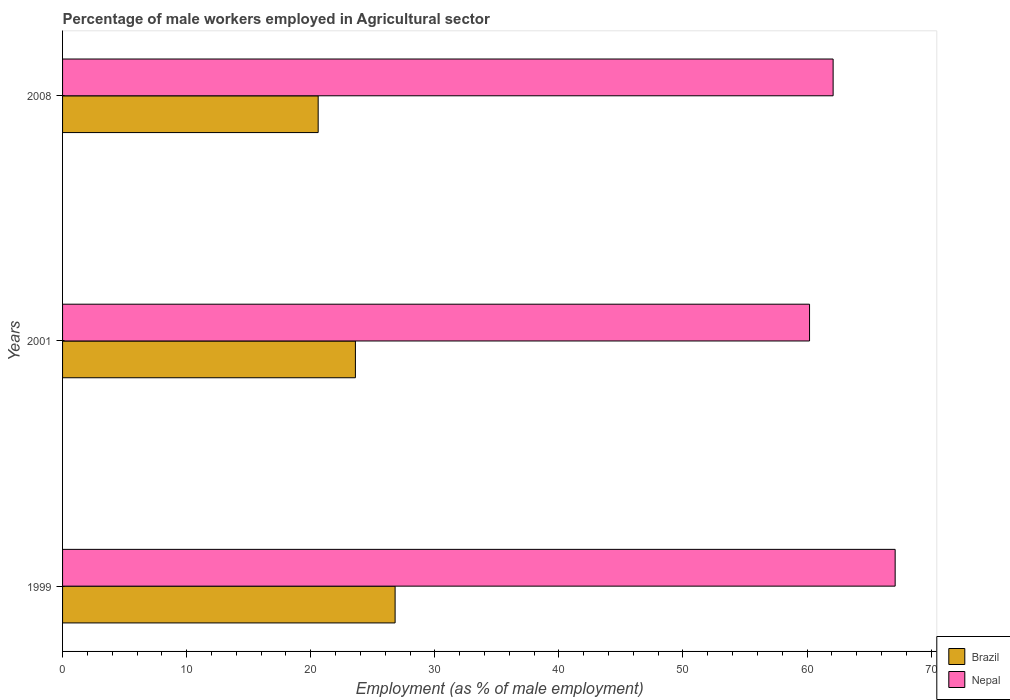How many groups of bars are there?
Your answer should be very brief. 3. Are the number of bars per tick equal to the number of legend labels?
Provide a succinct answer. Yes. What is the label of the 3rd group of bars from the top?
Give a very brief answer. 1999. What is the percentage of male workers employed in Agricultural sector in Nepal in 2008?
Provide a succinct answer. 62.1. Across all years, what is the maximum percentage of male workers employed in Agricultural sector in Nepal?
Your answer should be compact. 67.1. Across all years, what is the minimum percentage of male workers employed in Agricultural sector in Nepal?
Offer a very short reply. 60.2. In which year was the percentage of male workers employed in Agricultural sector in Nepal maximum?
Provide a short and direct response. 1999. What is the total percentage of male workers employed in Agricultural sector in Brazil in the graph?
Your response must be concise. 71. What is the difference between the percentage of male workers employed in Agricultural sector in Nepal in 1999 and that in 2001?
Ensure brevity in your answer.  6.9. What is the difference between the percentage of male workers employed in Agricultural sector in Brazil in 1999 and the percentage of male workers employed in Agricultural sector in Nepal in 2001?
Your answer should be very brief. -33.4. What is the average percentage of male workers employed in Agricultural sector in Brazil per year?
Provide a short and direct response. 23.67. In the year 2001, what is the difference between the percentage of male workers employed in Agricultural sector in Brazil and percentage of male workers employed in Agricultural sector in Nepal?
Provide a short and direct response. -36.6. In how many years, is the percentage of male workers employed in Agricultural sector in Nepal greater than 14 %?
Your response must be concise. 3. What is the ratio of the percentage of male workers employed in Agricultural sector in Brazil in 1999 to that in 2001?
Your answer should be compact. 1.14. Is the percentage of male workers employed in Agricultural sector in Brazil in 2001 less than that in 2008?
Provide a short and direct response. No. What is the difference between the highest and the second highest percentage of male workers employed in Agricultural sector in Brazil?
Provide a short and direct response. 3.2. What is the difference between the highest and the lowest percentage of male workers employed in Agricultural sector in Nepal?
Ensure brevity in your answer.  6.9. Is the sum of the percentage of male workers employed in Agricultural sector in Brazil in 1999 and 2001 greater than the maximum percentage of male workers employed in Agricultural sector in Nepal across all years?
Your answer should be compact. No. What does the 2nd bar from the bottom in 2008 represents?
Give a very brief answer. Nepal. How many years are there in the graph?
Keep it short and to the point. 3. What is the difference between two consecutive major ticks on the X-axis?
Provide a succinct answer. 10. Does the graph contain any zero values?
Give a very brief answer. No. Does the graph contain grids?
Keep it short and to the point. No. What is the title of the graph?
Provide a succinct answer. Percentage of male workers employed in Agricultural sector. What is the label or title of the X-axis?
Make the answer very short. Employment (as % of male employment). What is the label or title of the Y-axis?
Provide a succinct answer. Years. What is the Employment (as % of male employment) in Brazil in 1999?
Keep it short and to the point. 26.8. What is the Employment (as % of male employment) in Nepal in 1999?
Keep it short and to the point. 67.1. What is the Employment (as % of male employment) in Brazil in 2001?
Ensure brevity in your answer.  23.6. What is the Employment (as % of male employment) in Nepal in 2001?
Your answer should be compact. 60.2. What is the Employment (as % of male employment) in Brazil in 2008?
Offer a terse response. 20.6. What is the Employment (as % of male employment) of Nepal in 2008?
Provide a short and direct response. 62.1. Across all years, what is the maximum Employment (as % of male employment) in Brazil?
Offer a terse response. 26.8. Across all years, what is the maximum Employment (as % of male employment) in Nepal?
Offer a terse response. 67.1. Across all years, what is the minimum Employment (as % of male employment) in Brazil?
Offer a terse response. 20.6. Across all years, what is the minimum Employment (as % of male employment) in Nepal?
Give a very brief answer. 60.2. What is the total Employment (as % of male employment) of Brazil in the graph?
Give a very brief answer. 71. What is the total Employment (as % of male employment) in Nepal in the graph?
Offer a terse response. 189.4. What is the difference between the Employment (as % of male employment) in Brazil in 1999 and that in 2008?
Offer a terse response. 6.2. What is the difference between the Employment (as % of male employment) of Nepal in 1999 and that in 2008?
Give a very brief answer. 5. What is the difference between the Employment (as % of male employment) of Brazil in 2001 and that in 2008?
Give a very brief answer. 3. What is the difference between the Employment (as % of male employment) in Nepal in 2001 and that in 2008?
Provide a short and direct response. -1.9. What is the difference between the Employment (as % of male employment) of Brazil in 1999 and the Employment (as % of male employment) of Nepal in 2001?
Provide a succinct answer. -33.4. What is the difference between the Employment (as % of male employment) of Brazil in 1999 and the Employment (as % of male employment) of Nepal in 2008?
Keep it short and to the point. -35.3. What is the difference between the Employment (as % of male employment) in Brazil in 2001 and the Employment (as % of male employment) in Nepal in 2008?
Give a very brief answer. -38.5. What is the average Employment (as % of male employment) in Brazil per year?
Offer a very short reply. 23.67. What is the average Employment (as % of male employment) in Nepal per year?
Provide a short and direct response. 63.13. In the year 1999, what is the difference between the Employment (as % of male employment) in Brazil and Employment (as % of male employment) in Nepal?
Keep it short and to the point. -40.3. In the year 2001, what is the difference between the Employment (as % of male employment) in Brazil and Employment (as % of male employment) in Nepal?
Give a very brief answer. -36.6. In the year 2008, what is the difference between the Employment (as % of male employment) of Brazil and Employment (as % of male employment) of Nepal?
Your response must be concise. -41.5. What is the ratio of the Employment (as % of male employment) in Brazil in 1999 to that in 2001?
Your response must be concise. 1.14. What is the ratio of the Employment (as % of male employment) of Nepal in 1999 to that in 2001?
Offer a terse response. 1.11. What is the ratio of the Employment (as % of male employment) of Brazil in 1999 to that in 2008?
Offer a terse response. 1.3. What is the ratio of the Employment (as % of male employment) in Nepal in 1999 to that in 2008?
Give a very brief answer. 1.08. What is the ratio of the Employment (as % of male employment) in Brazil in 2001 to that in 2008?
Provide a succinct answer. 1.15. What is the ratio of the Employment (as % of male employment) in Nepal in 2001 to that in 2008?
Provide a succinct answer. 0.97. What is the difference between the highest and the second highest Employment (as % of male employment) in Brazil?
Your response must be concise. 3.2. What is the difference between the highest and the second highest Employment (as % of male employment) in Nepal?
Provide a short and direct response. 5. 